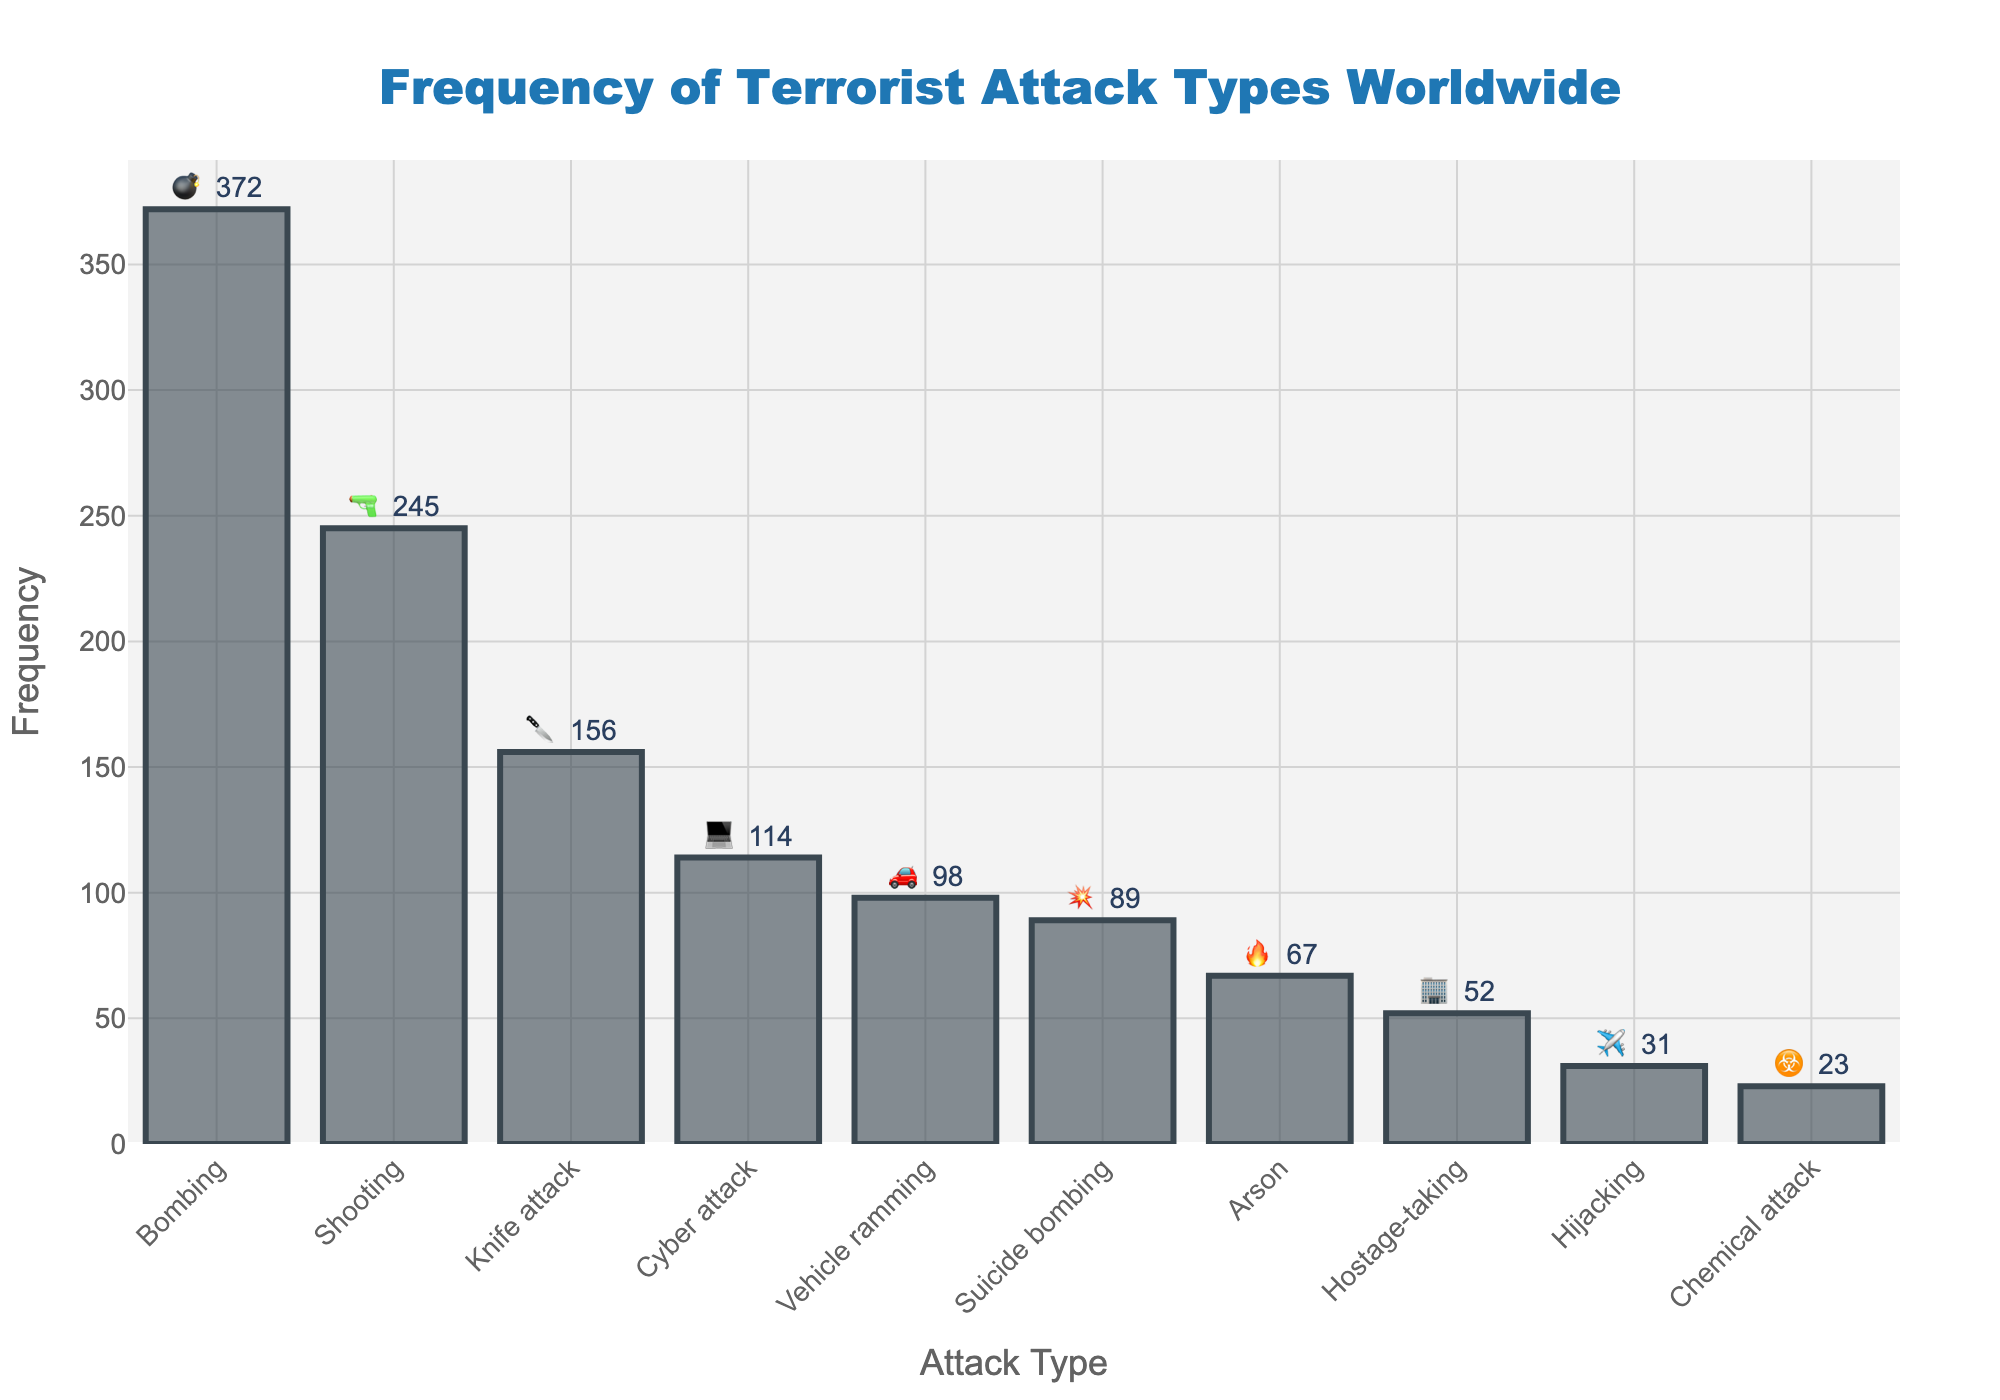What is the most common type of terrorist attack? The most common type of terrorist attack is represented by the longest bar in the chart. The longest bar is for bombing attacks.
Answer: Bombing How many more shooting attacks are there compared to knife attacks? To find the difference, subtract the frequency of knife attacks from the frequency of shooting attacks. Shooting attacks have a frequency of 245, and knife attacks have a frequency of 156. So, 245 - 156 = 89.
Answer: 89 Which type of terrorist attack appears third most frequently? Looking at the lengths of the bars, the third longest bar represents knife attacks, which have a frequency of 156.
Answer: Knife attack List the attack types that have a frequency below 100. Identify bars that are shorter than those representing a frequency of 100. The types are vehicle ramming, arson, chemical attack, hijacking, hostage-taking, and suicide bombing.
Answer: Vehicle ramming, Arson, Chemical attack, Hijacking, Hostage-taking, Suicide bombing What is the combined frequency of cyber and suicide bombing attacks? Add the frequencies of cyber attacks and suicide bombing attacks. Cyber attacks have a frequency of 114, and suicide bombing attacks have a frequency of 89. So, 114 + 89 = 203.
Answer: 203 Which attack type has the least frequency and what is its emoji? The attack type with the least frequency is represented by the shortest bar in the chart. Chemical attacks have the least frequency, with an emoji of ☣️.
Answer: Chemical attack, ☣️ How many attack types have a frequency above 100? Count the bars that exceed the 100 frequency mark. Bombing, shooting, knife attack, and cyber attack all have frequencies above 100.
Answer: 4 What is the difference in frequency between the most and least common attack types? Subtract the frequency of the least common attack type (chemical attack, 23) from the frequency of the most common attack type (bombing, 372). So, 372 - 23 = 349.
Answer: 349 Rank the top three most frequent attack types and provide their emojis. Identify the three longest bars to find bombing (💣), shooting (🔫), and knife attack (🔪).
Answer: Bombing (💣), Shooting (🔫), Knife attack (🔪) 